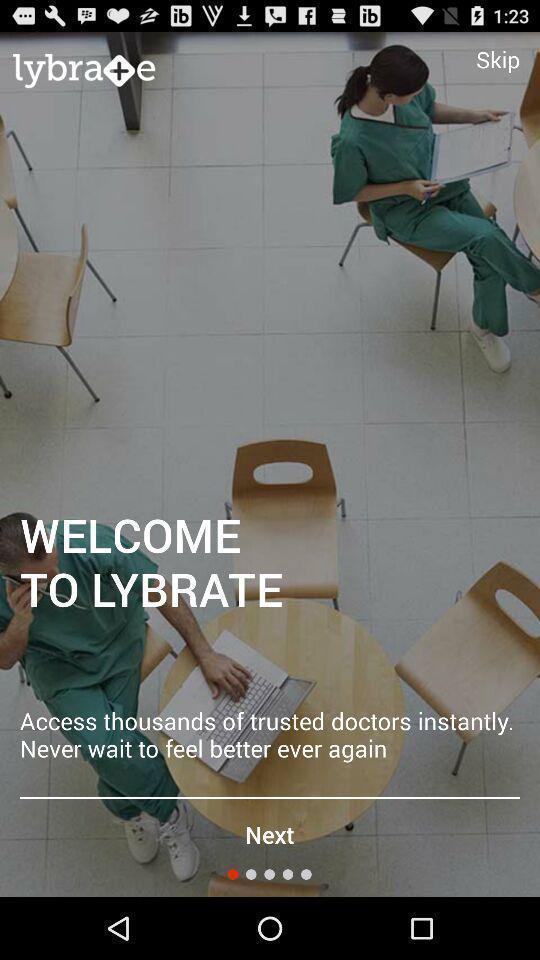Describe the key features of this screenshot. Welcome page with next option. 